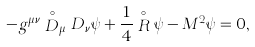<formula> <loc_0><loc_0><loc_500><loc_500>- g ^ { \mu \nu } \stackrel { \circ } { D } _ { \mu } D _ { \nu } \psi + \frac { 1 } { 4 } \stackrel { \circ } { R } \psi - M ^ { 2 } \psi = 0 ,</formula> 